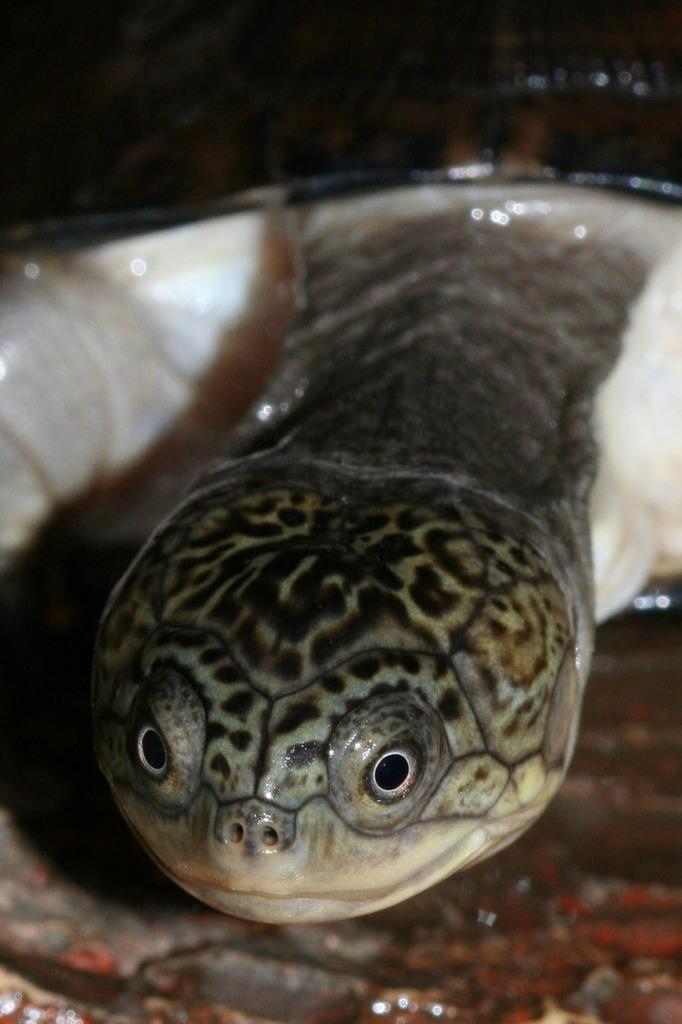What type of animal is in the image? There is a tortoise in the image. What type of elbow can be seen in the image? There is no elbow present in the image; it features a tortoise. What type of fork is the tortoise using to play in the image? There is no fork or indication of the tortoise playing in the image; it is simply a tortoise in the image. 